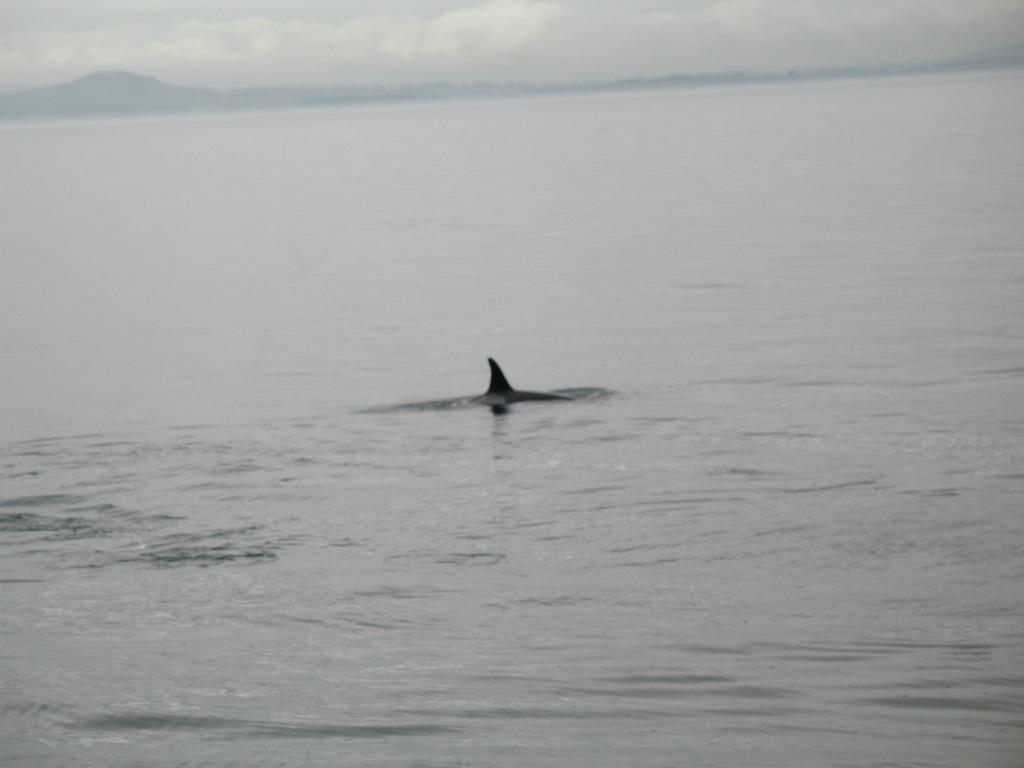Describe this image in one or two sentences. Here in this picture we can see a whale present in the water, as we can see water present all over there and in the far we can see mountains present and we can see clouds in the sky. 